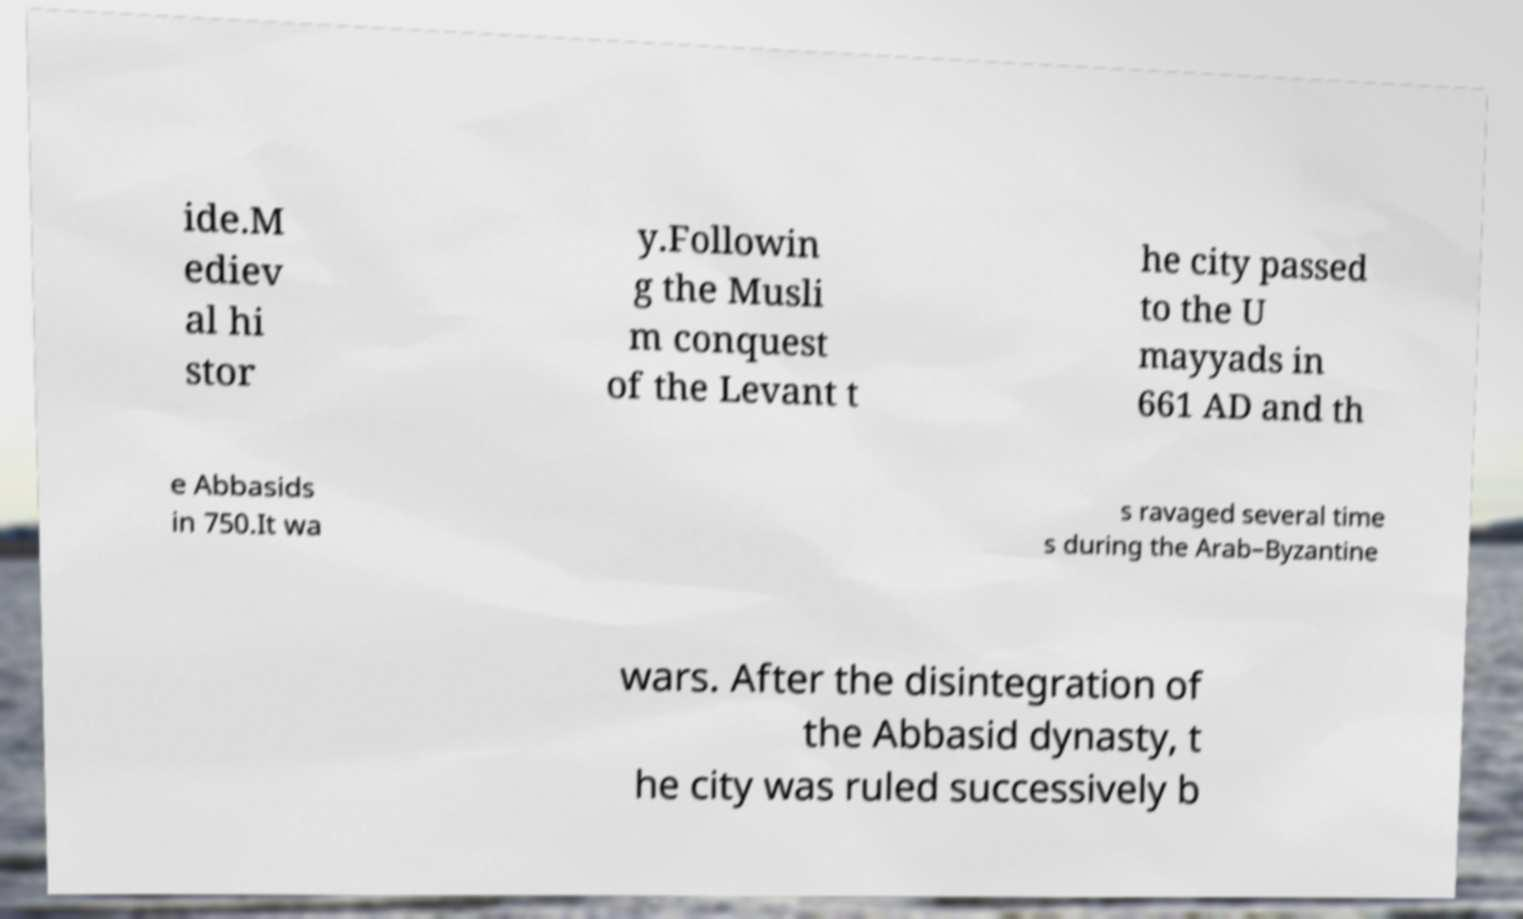Please identify and transcribe the text found in this image. ide.M ediev al hi stor y.Followin g the Musli m conquest of the Levant t he city passed to the U mayyads in 661 AD and th e Abbasids in 750.It wa s ravaged several time s during the Arab–Byzantine wars. After the disintegration of the Abbasid dynasty, t he city was ruled successively b 